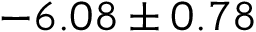<formula> <loc_0><loc_0><loc_500><loc_500>- 6 . 0 8 \pm 0 . 7 8</formula> 